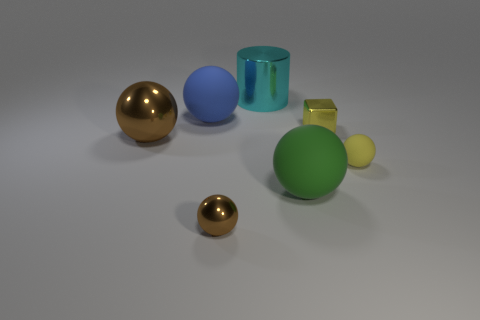Is the number of big cyan objects in front of the small brown sphere the same as the number of cyan metal cylinders left of the large brown shiny ball?
Your answer should be very brief. Yes. What color is the matte ball that is the same size as the blue thing?
Provide a short and direct response. Green. How many small objects are metal blocks or cyan metal balls?
Provide a succinct answer. 1. The big object that is on the right side of the blue thing and in front of the big blue rubber sphere is made of what material?
Ensure brevity in your answer.  Rubber. There is a brown object that is on the left side of the big blue thing; is it the same shape as the matte object that is on the left side of the small brown sphere?
Give a very brief answer. Yes. There is a tiny thing that is the same color as the small matte sphere; what is its shape?
Your response must be concise. Cube. What number of things are either large balls on the left side of the large cylinder or yellow rubber things?
Keep it short and to the point. 3. Do the yellow matte object and the block have the same size?
Give a very brief answer. Yes. What is the color of the tiny metallic object left of the cyan metallic thing?
Offer a terse response. Brown. What is the size of the yellow ball that is the same material as the blue thing?
Your answer should be very brief. Small. 